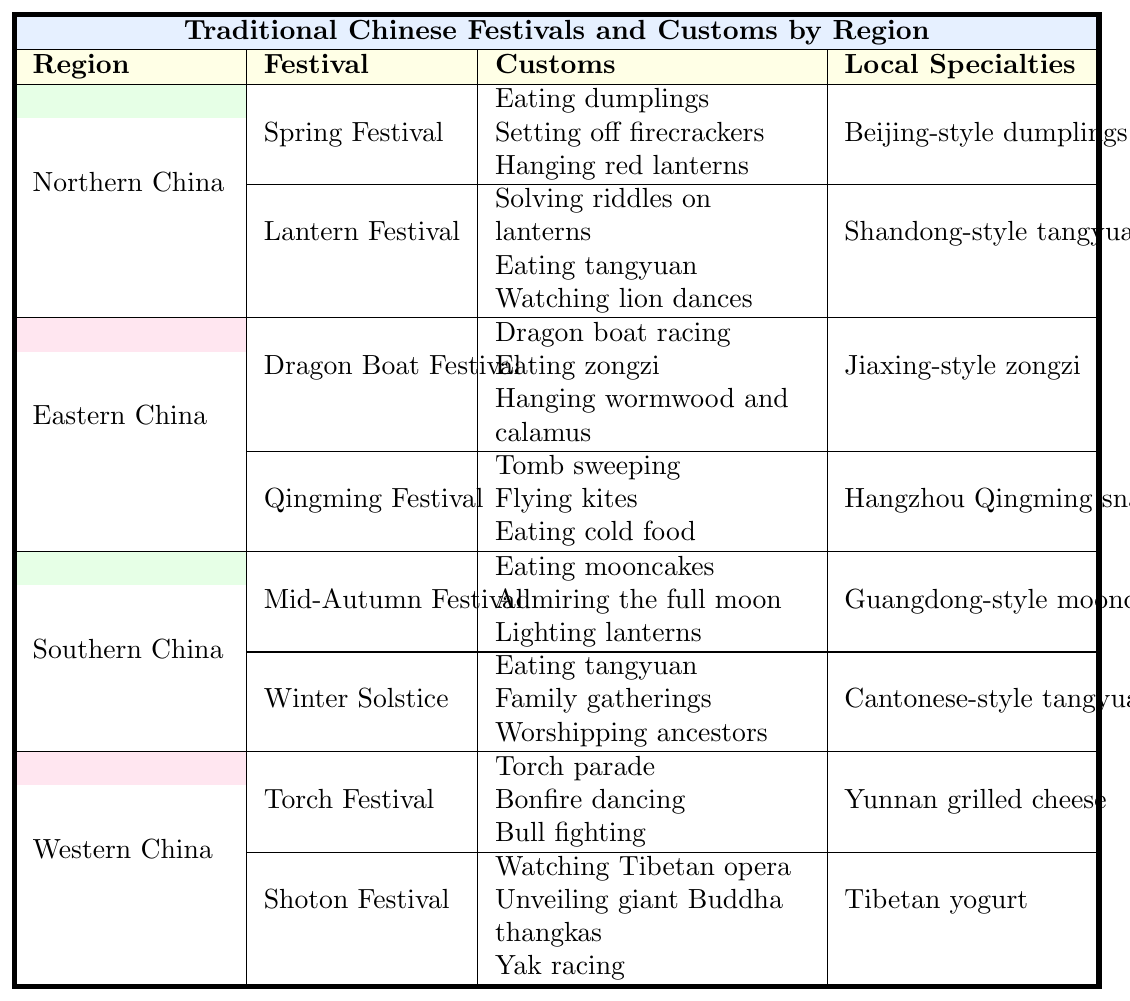What festival is celebrated in Northern China that involves eating dumplings? According to the table, the Spring Festival is celebrated in Northern China and includes the custom of eating dumplings.
Answer: Spring Festival Which Southern Chinese festival includes lighting lanterns? The table indicates that the Mid-Autumn Festival, celebrated in Southern China, includes the custom of lighting lanterns.
Answer: Mid-Autumn Festival Are tangyuan eaten during both the Winter Solstice and the Lantern Festival? Looking at the table, tangyuan is listed under both the Winter Solstice and Lantern Festival, confirming that they are eaten during both festivals.
Answer: Yes What is the local specialty associated with the Dragon Boat Festival? The table specifies that the local specialty related to the Dragon Boat Festival is Jiaxing-style zongzi.
Answer: Jiaxing-style zongzi Which two festivals in Eastern China involve activities related to kites? The table shows that only the Qingming Festival involves flying kites. The Dragon Boat Festival does not include this activity. Thus, there is only one festival related to kites.
Answer: 1 (Qingming Festival) What percentage of festivals listed in Northern China involve fire-related customs? In Northern China, there are two festivals: Spring Festival and Lantern Festival. The Spring Festival includes setting off firecrackers, which is a fire-related custom. Thus, 1 out of 2 is 50%.
Answer: 50% Which region does the Torch Festival belong to, and what is a unique custom associated with it? The table states that the Torch Festival belongs to Western China, and one unique custom associated with it is the torch parade.
Answer: Western China; torch parade What are the customs associated with the Winter Solstice in Southern China? The table outlines the customs for the Winter Solstice in Southern China as eating tangyuan, family gatherings, and worshipping ancestors.
Answer: Eating tangyuan, family gatherings, worshipping ancestors Identify the festival in Eastern China that involves tomb sweeping. The table specifies that the Qingming Festival in Eastern China involves the custom of tomb sweeping.
Answer: Qingming Festival Which region has the most festivals listed, and how many festivals are featured there? Consulting the table, Northern China, Eastern China, Southern China, and Western China each have two festivals listed, hence none has more than the others. All regions have the same count of festivals.
Answer: None; 2 festivals each 